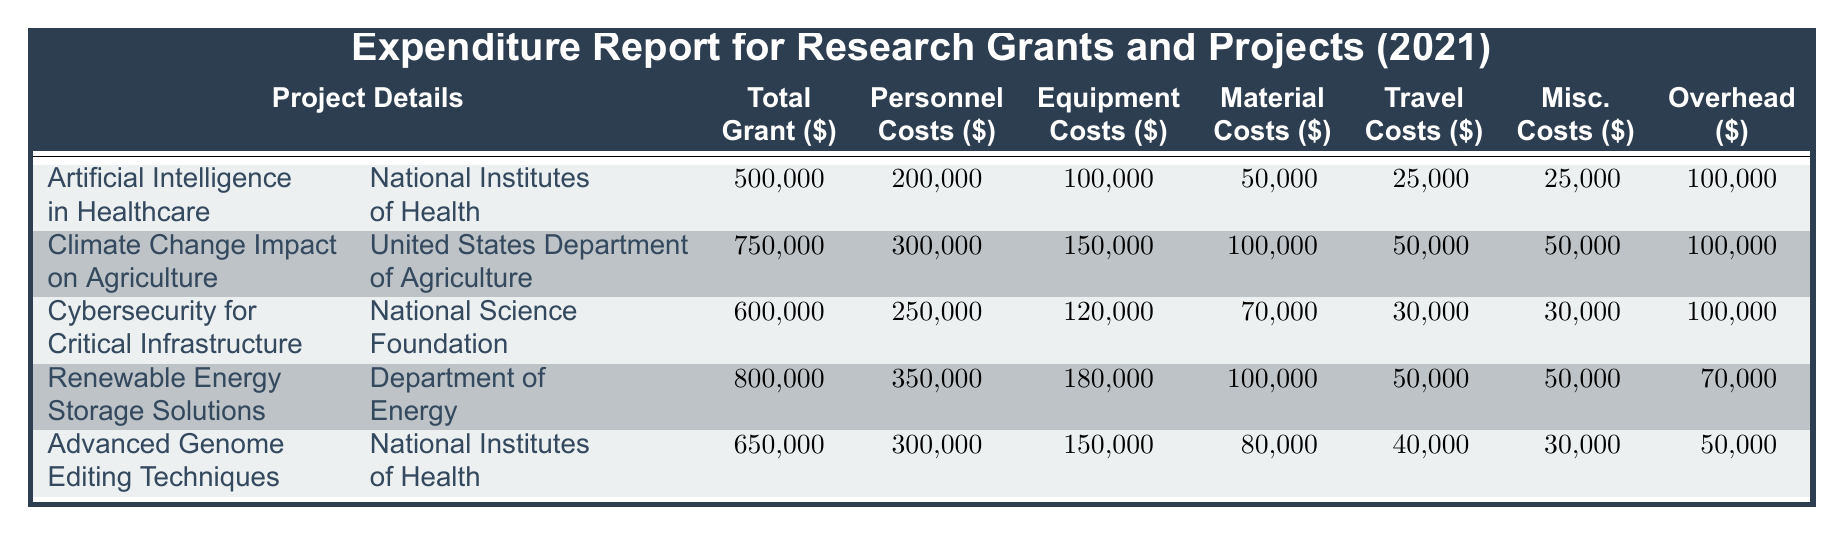What is the total grant for the "Cybersecurity for Critical Infrastructure" project? The total grant for the "Cybersecurity for Critical Infrastructure" project can be found in the Total Grant column of the corresponding row. It shows 600000.
Answer: 600000 Which project has the highest personnel costs? To find the project with the highest personnel costs, we compare the Personnel Costs across all projects: 200000, 300000, 250000, 350000, and 300000. The maximum is 350000 for the "Renewable Energy Storage Solutions" project.
Answer: Renewable Energy Storage Solutions What is the average equipment cost across all projects? The equipment costs are 100000, 150000, 120000, 180000, and 150000. Their sum is 100000 + 150000 + 120000 + 180000 + 150000 = 700000. Dividing this sum by the number of projects (5) gives an average of 700000/5 = 140000.
Answer: 140000 Is the total grant for the "Advanced Genome Editing Techniques" project more than 600000? The total grant for this project is listed as 650000 in the table. Since 650000 is greater than 600000, the answer is yes.
Answer: Yes Which project had the lowest travel costs and what was that amount? The travel costs for each project are: 25000, 50000, 30000, 50000, and 40000. The lowest amount is 25000, corresponding to the "Artificial Intelligence in Healthcare" project.
Answer: 25000 What is the total amount spent on miscellaneous costs for all projects? The miscellaneous costs are 25000, 50000, 30000, 50000, and 30000. Adding these gives 25000 + 50000 + 30000 + 50000 + 30000 = 185000 as the total amount spent on miscellaneous costs.
Answer: 185000 Which funding agency provided the grant with the second highest total grant amount? The total grants are: 500000 (National Institutes of Health), 750000 (United States Department of Agriculture), 600000 (National Science Foundation), 800000 (Department of Energy), and 650000 (National Institutes of Health). The second highest amount is 750000, which corresponds to the United States Department of Agriculture.
Answer: United States Department of Agriculture What is the difference in overhead costs between the "Climate Change Impact on Agriculture" and "Cybersecurity for Critical Infrastructure" projects? The overhead cost for "Climate Change Impact on Agriculture" is 100000, while for "Cybersecurity for Critical Infrastructure", it is also 100000. The difference is 100000 - 100000 = 0.
Answer: 0 